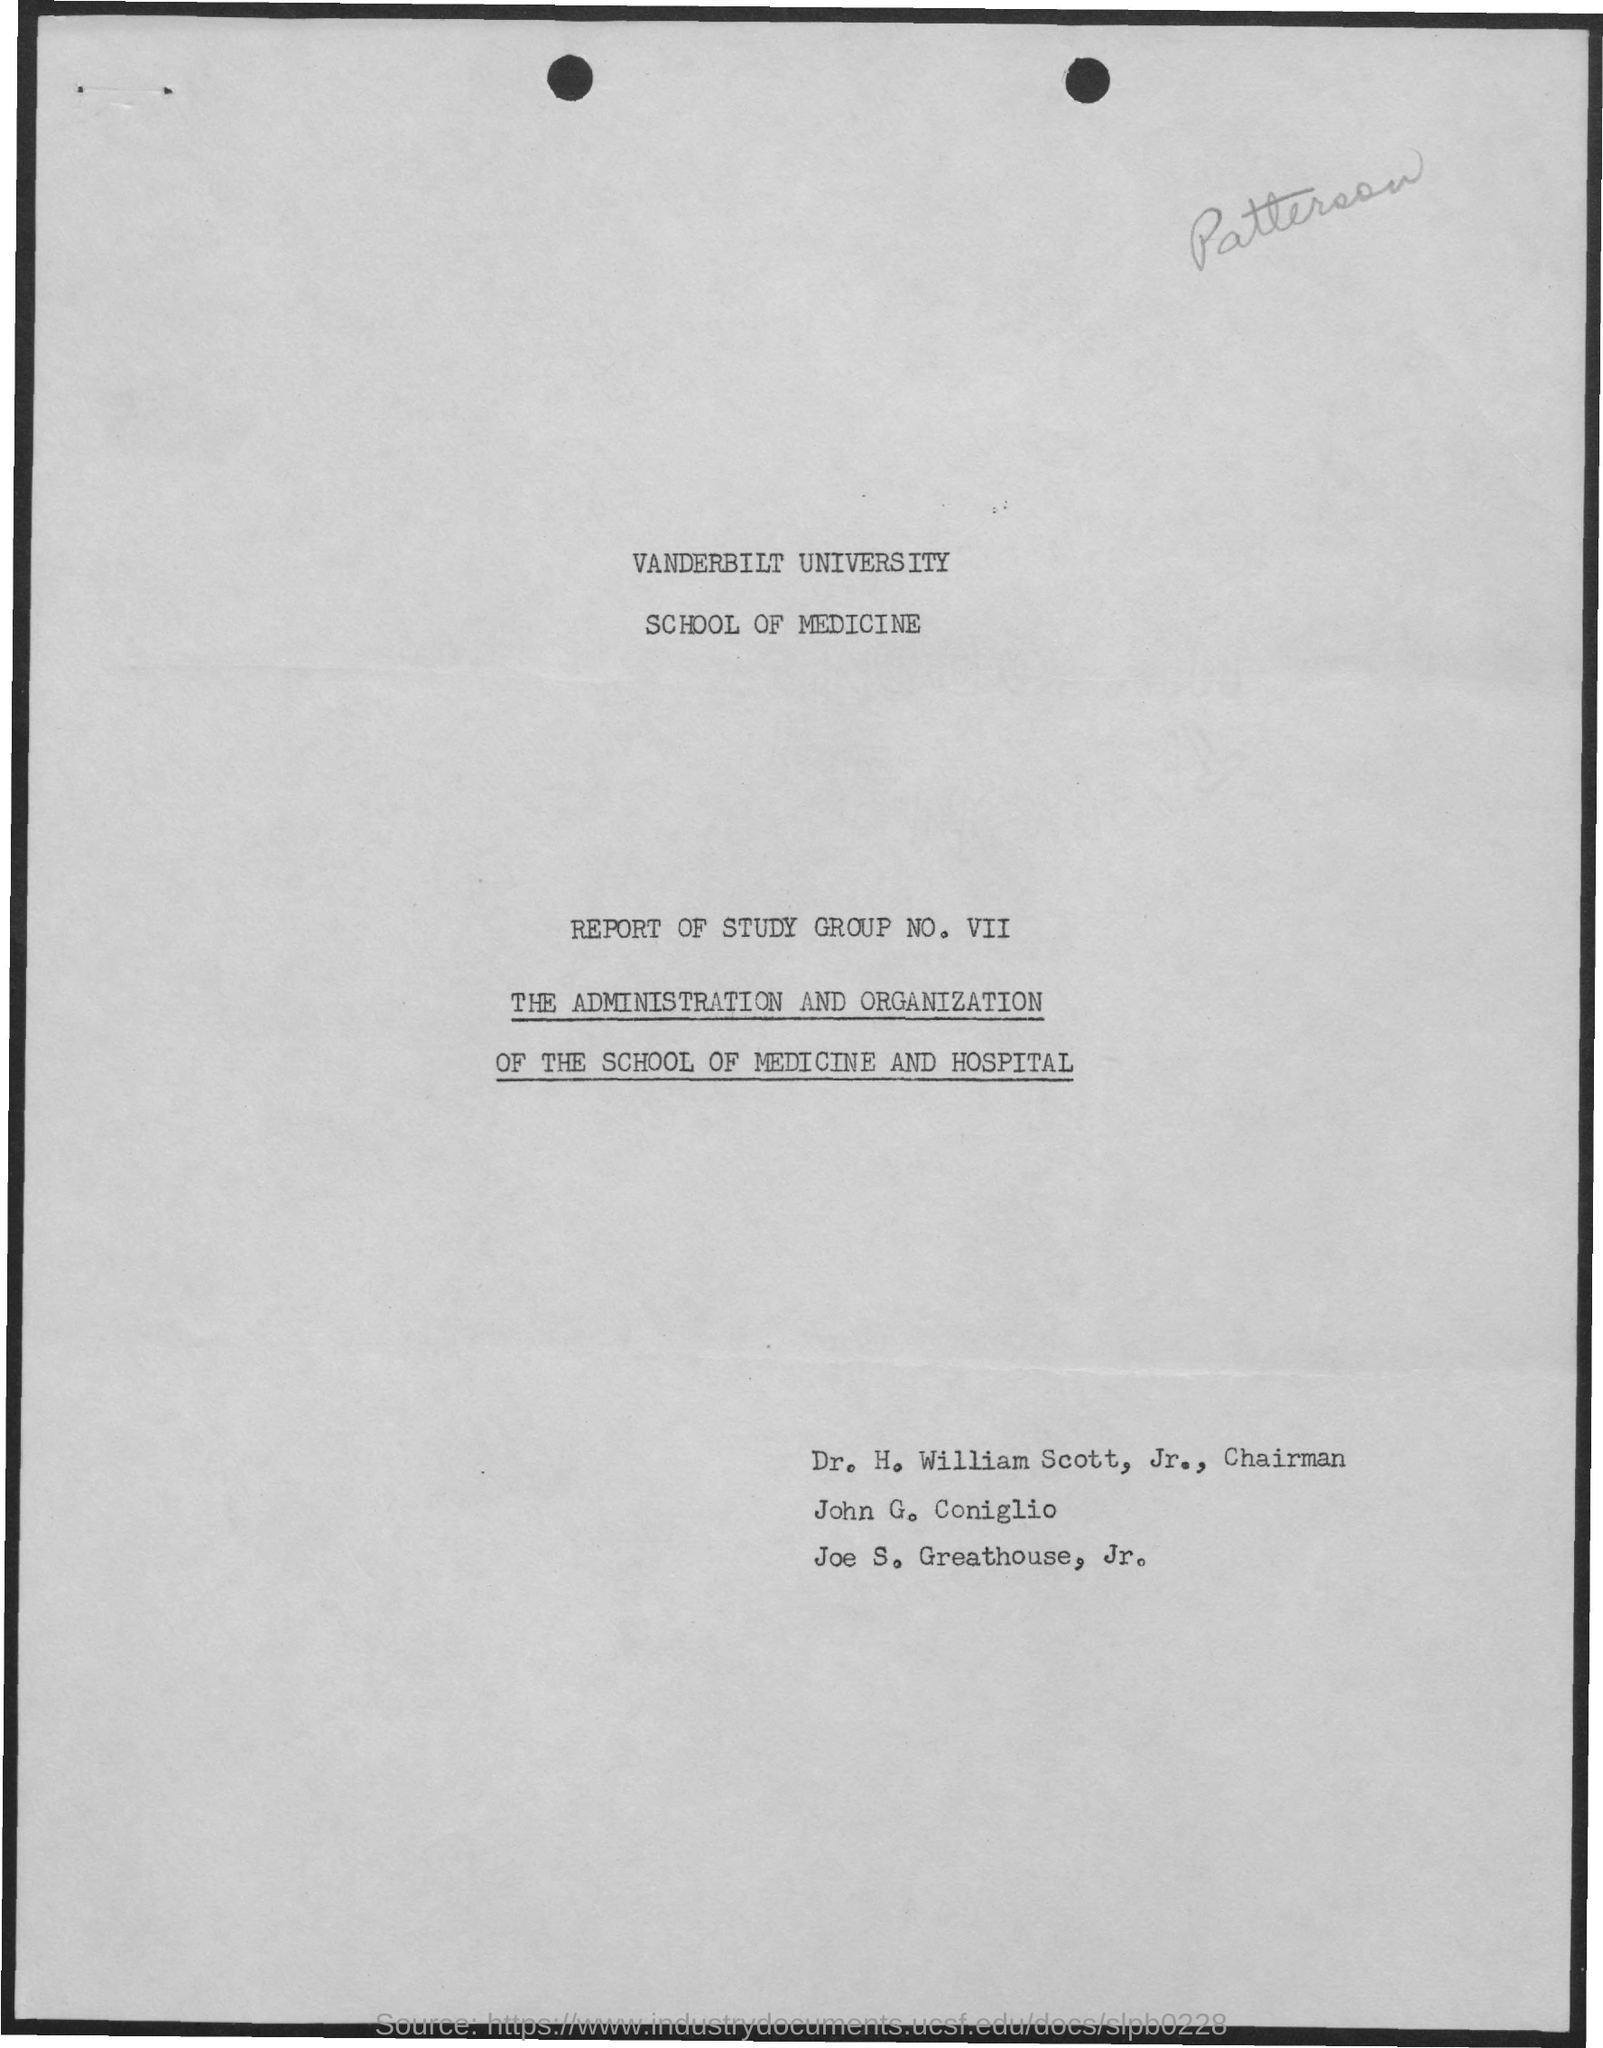What is the group number mentioned?
Offer a terse response. VII. 